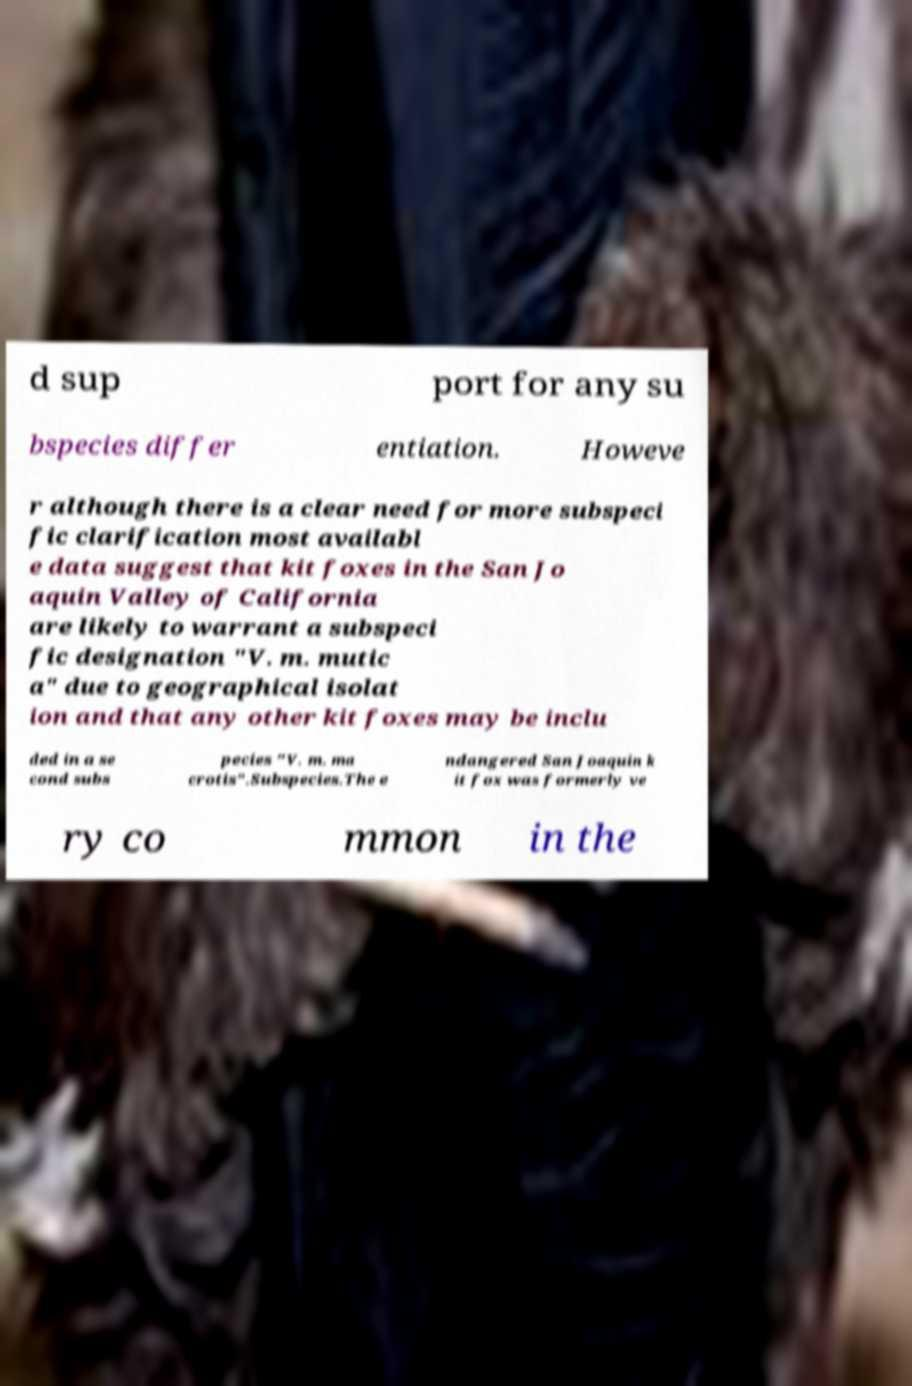Can you accurately transcribe the text from the provided image for me? d sup port for any su bspecies differ entiation. Howeve r although there is a clear need for more subspeci fic clarification most availabl e data suggest that kit foxes in the San Jo aquin Valley of California are likely to warrant a subspeci fic designation "V. m. mutic a" due to geographical isolat ion and that any other kit foxes may be inclu ded in a se cond subs pecies "V. m. ma crotis".Subspecies.The e ndangered San Joaquin k it fox was formerly ve ry co mmon in the 